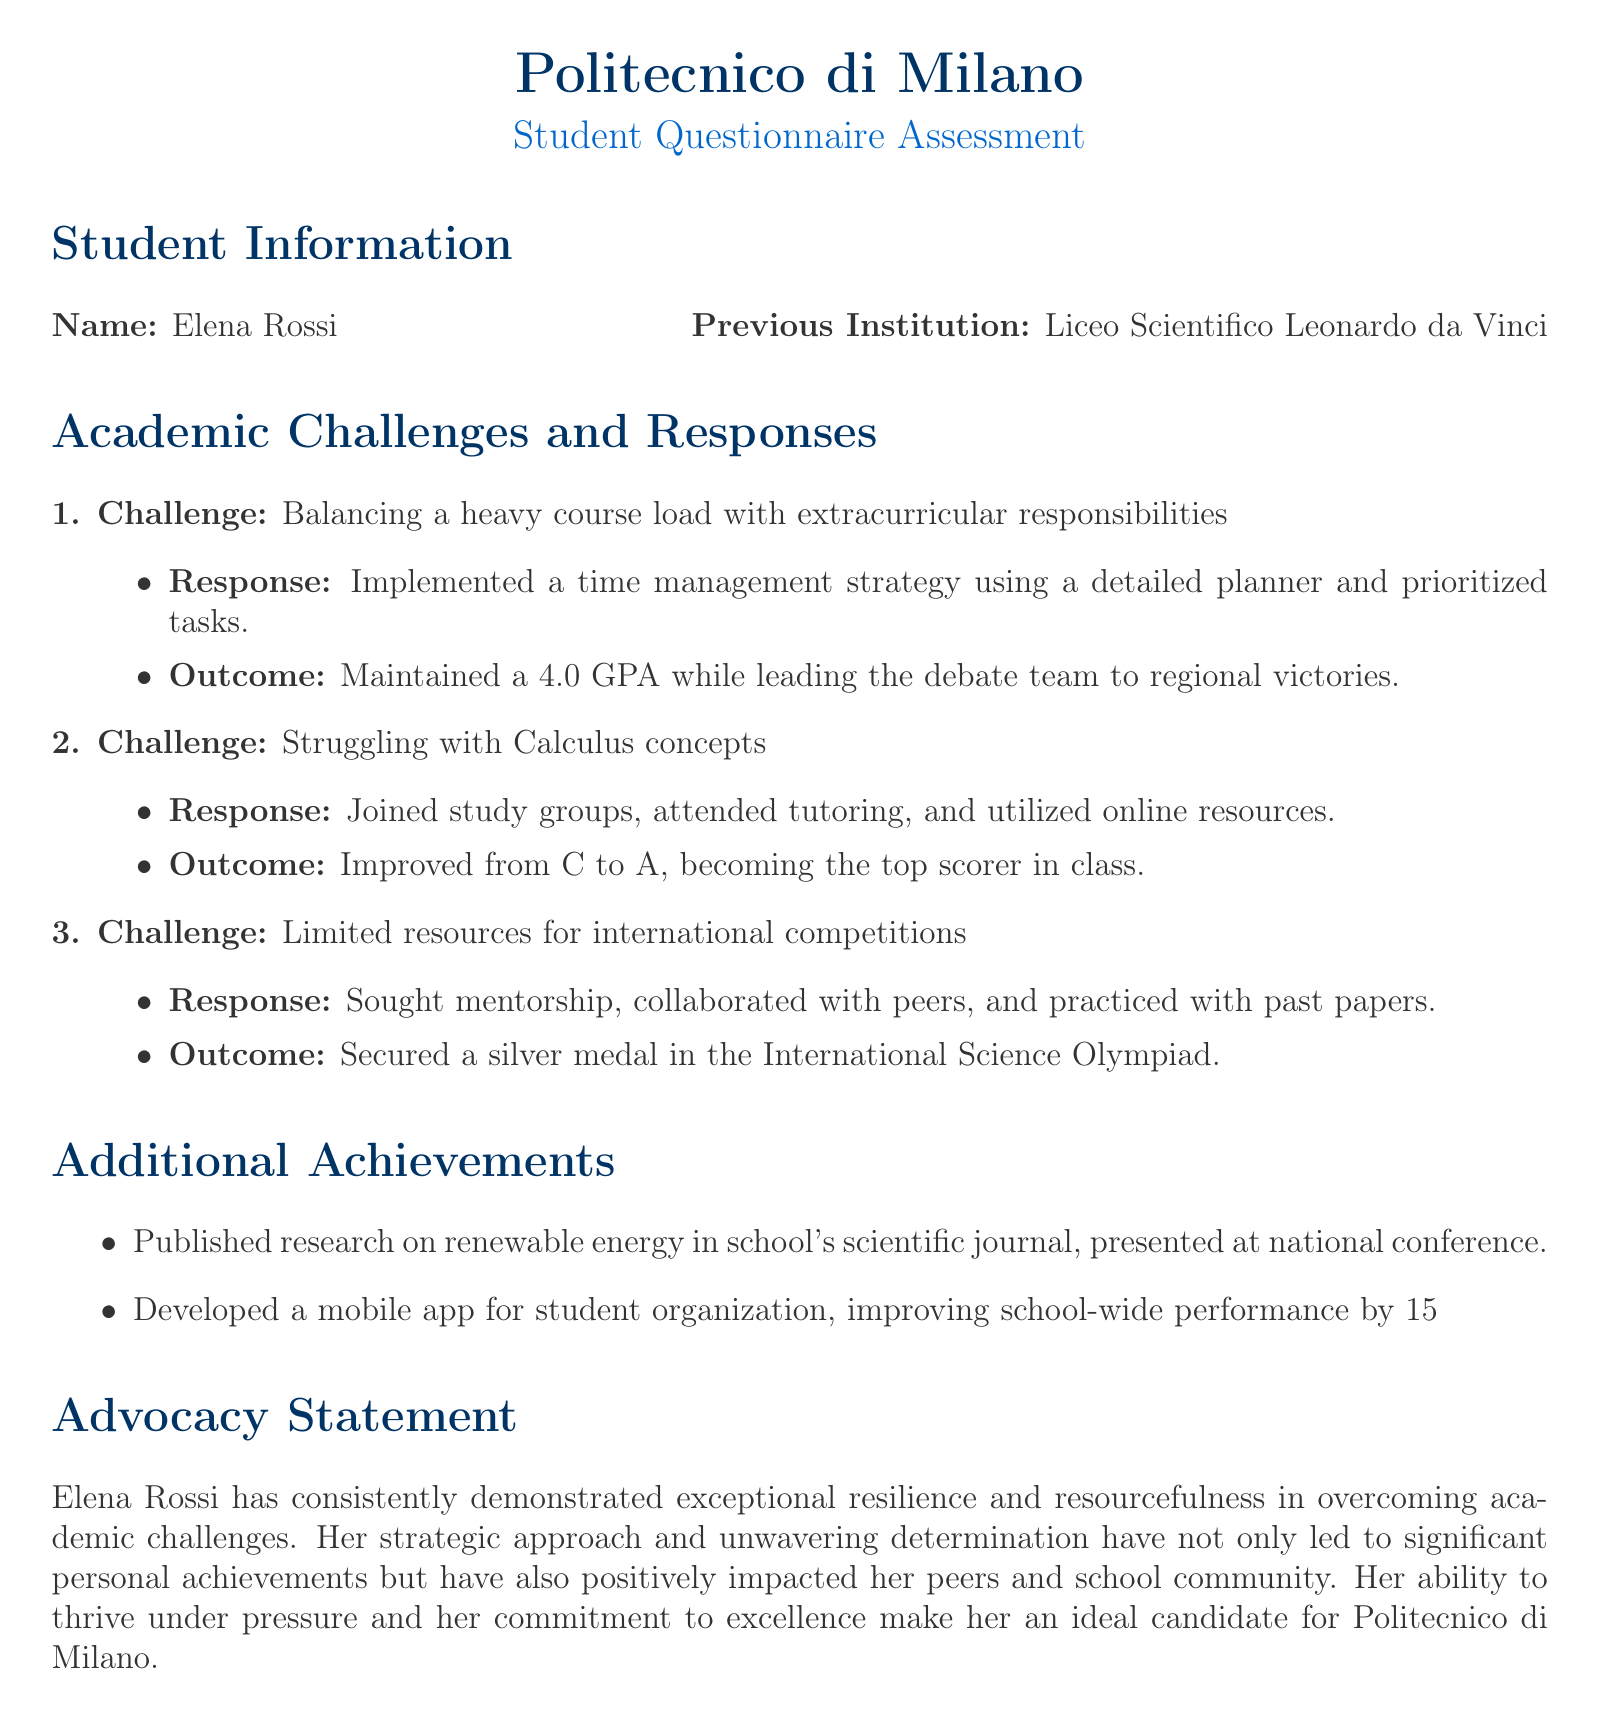What is the name of the student? The name of the student is stated in the Student Information section of the document.
Answer: Elena Rossi What was Elena's previous institution? The previous institution is mentioned in the Student Information section.
Answer: Liceo Scientifico Leonardo da Vinci What was the GPA that Elena maintained? The GPA is mentioned in the outcome of the first challenge.
Answer: 4.0 What medal did Elena secure in the International Science Olympiad? The achievement of securing a medal is mentioned in the response to limited resources for competitions.
Answer: Silver What significant topic did Elena publish research on? The topic of the research is mentioned in the Additional Achievements section.
Answer: Renewable energy How did Elena improve her Calculus grade? The methods of improvement for her Calculus grade are outlined in the response to the second challenge.
Answer: Study groups, tutoring, online resources What mobile development did Elena complete? The mobile app project is described in the Additional Achievements section.
Answer: Mobile app for student organization Which team did Elena lead to regional victories? The team is identified in the outcome of the first challenge.
Answer: Debate team What was the result of Elena's involvement in the scientific journal? The outcome of her publication is discussed in the Additional Achievements section.
Answer: Presented at national conference 